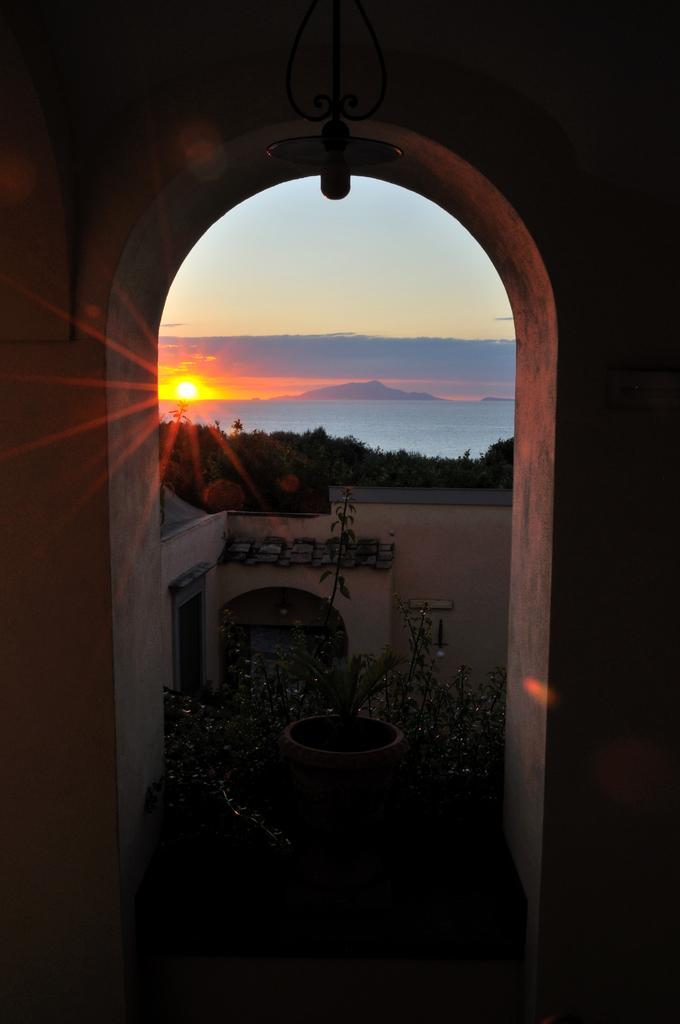Describe this image in one or two sentences. In this image in the front there is an arch and in the center there are plants, there is a wall and in the background there are trees, there is water, there are mountains and there is a sun visible in the sky. 